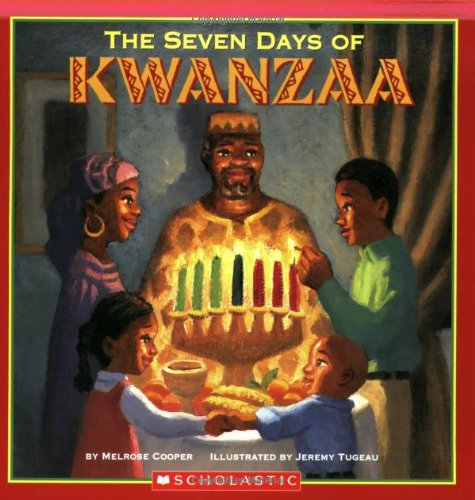What might be a main theme discussed in this book? A main theme in 'The Seven Days Of Kwanzaa' is likely to be the celebration of cultural values and unity, reflecting the principles of the Kwanzaa festival itself. 